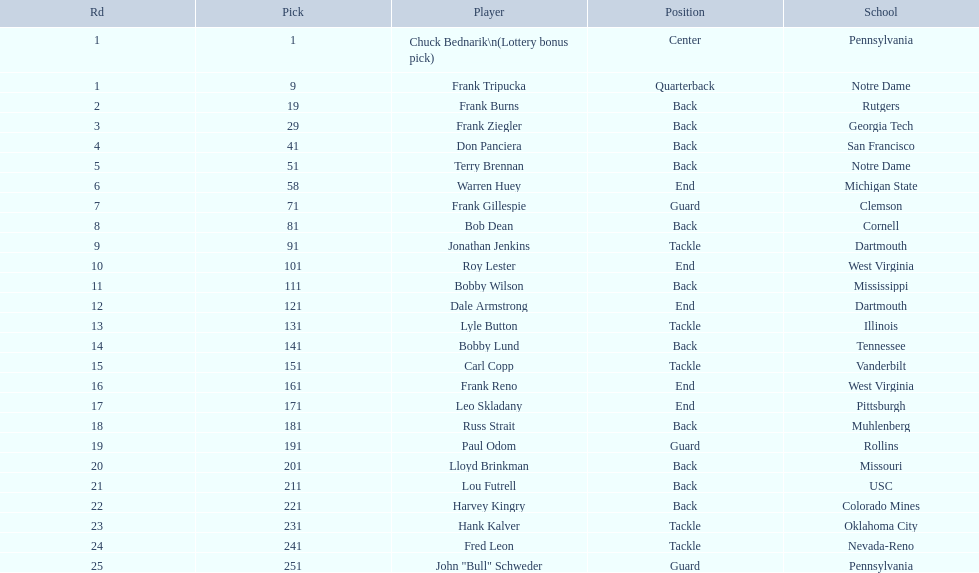For most players, what position did they occupy? Back. 